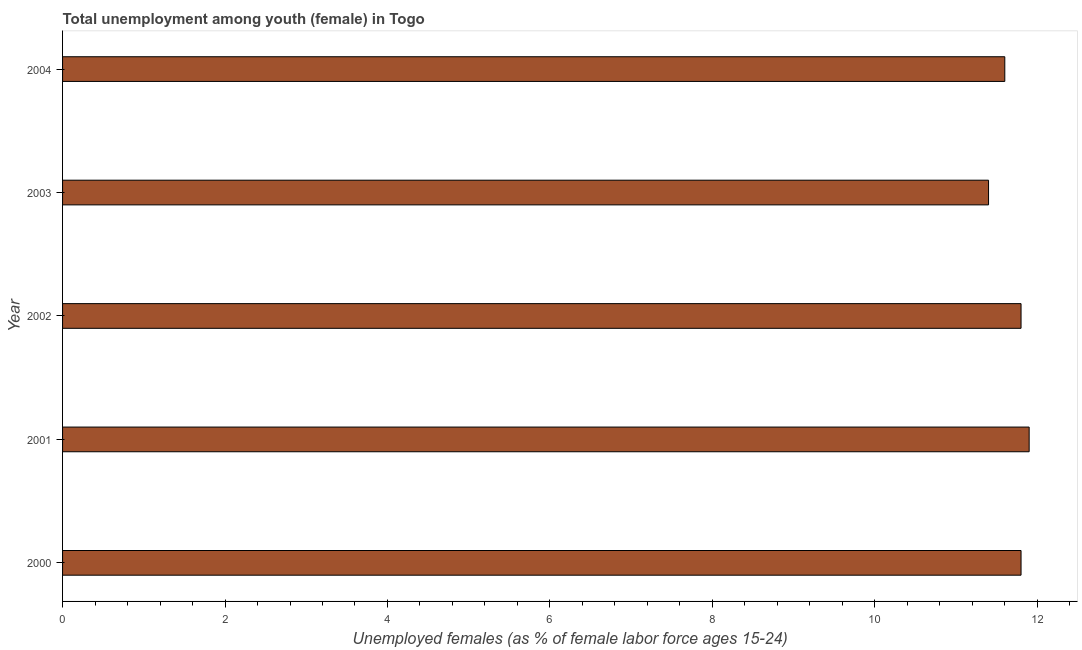Does the graph contain any zero values?
Your response must be concise. No. Does the graph contain grids?
Your answer should be compact. No. What is the title of the graph?
Your answer should be very brief. Total unemployment among youth (female) in Togo. What is the label or title of the X-axis?
Your answer should be very brief. Unemployed females (as % of female labor force ages 15-24). What is the label or title of the Y-axis?
Give a very brief answer. Year. What is the unemployed female youth population in 2002?
Make the answer very short. 11.8. Across all years, what is the maximum unemployed female youth population?
Make the answer very short. 11.9. Across all years, what is the minimum unemployed female youth population?
Offer a very short reply. 11.4. What is the sum of the unemployed female youth population?
Give a very brief answer. 58.5. What is the average unemployed female youth population per year?
Offer a terse response. 11.7. What is the median unemployed female youth population?
Keep it short and to the point. 11.8. In how many years, is the unemployed female youth population greater than 0.4 %?
Provide a short and direct response. 5. What is the ratio of the unemployed female youth population in 2000 to that in 2003?
Ensure brevity in your answer.  1.03. Is the unemployed female youth population in 2002 less than that in 2003?
Offer a very short reply. No. What is the difference between the highest and the lowest unemployed female youth population?
Your response must be concise. 0.5. In how many years, is the unemployed female youth population greater than the average unemployed female youth population taken over all years?
Make the answer very short. 3. How many years are there in the graph?
Offer a terse response. 5. Are the values on the major ticks of X-axis written in scientific E-notation?
Your answer should be very brief. No. What is the Unemployed females (as % of female labor force ages 15-24) in 2000?
Offer a very short reply. 11.8. What is the Unemployed females (as % of female labor force ages 15-24) in 2001?
Offer a very short reply. 11.9. What is the Unemployed females (as % of female labor force ages 15-24) in 2002?
Offer a very short reply. 11.8. What is the Unemployed females (as % of female labor force ages 15-24) in 2003?
Your response must be concise. 11.4. What is the Unemployed females (as % of female labor force ages 15-24) of 2004?
Offer a terse response. 11.6. What is the difference between the Unemployed females (as % of female labor force ages 15-24) in 2000 and 2003?
Provide a short and direct response. 0.4. What is the difference between the Unemployed females (as % of female labor force ages 15-24) in 2001 and 2003?
Give a very brief answer. 0.5. What is the difference between the Unemployed females (as % of female labor force ages 15-24) in 2002 and 2003?
Your response must be concise. 0.4. What is the difference between the Unemployed females (as % of female labor force ages 15-24) in 2002 and 2004?
Give a very brief answer. 0.2. What is the difference between the Unemployed females (as % of female labor force ages 15-24) in 2003 and 2004?
Keep it short and to the point. -0.2. What is the ratio of the Unemployed females (as % of female labor force ages 15-24) in 2000 to that in 2001?
Make the answer very short. 0.99. What is the ratio of the Unemployed females (as % of female labor force ages 15-24) in 2000 to that in 2002?
Make the answer very short. 1. What is the ratio of the Unemployed females (as % of female labor force ages 15-24) in 2000 to that in 2003?
Provide a short and direct response. 1.03. What is the ratio of the Unemployed females (as % of female labor force ages 15-24) in 2000 to that in 2004?
Keep it short and to the point. 1.02. What is the ratio of the Unemployed females (as % of female labor force ages 15-24) in 2001 to that in 2002?
Your answer should be very brief. 1.01. What is the ratio of the Unemployed females (as % of female labor force ages 15-24) in 2001 to that in 2003?
Offer a very short reply. 1.04. What is the ratio of the Unemployed females (as % of female labor force ages 15-24) in 2002 to that in 2003?
Your answer should be compact. 1.03. What is the ratio of the Unemployed females (as % of female labor force ages 15-24) in 2002 to that in 2004?
Provide a succinct answer. 1.02. 